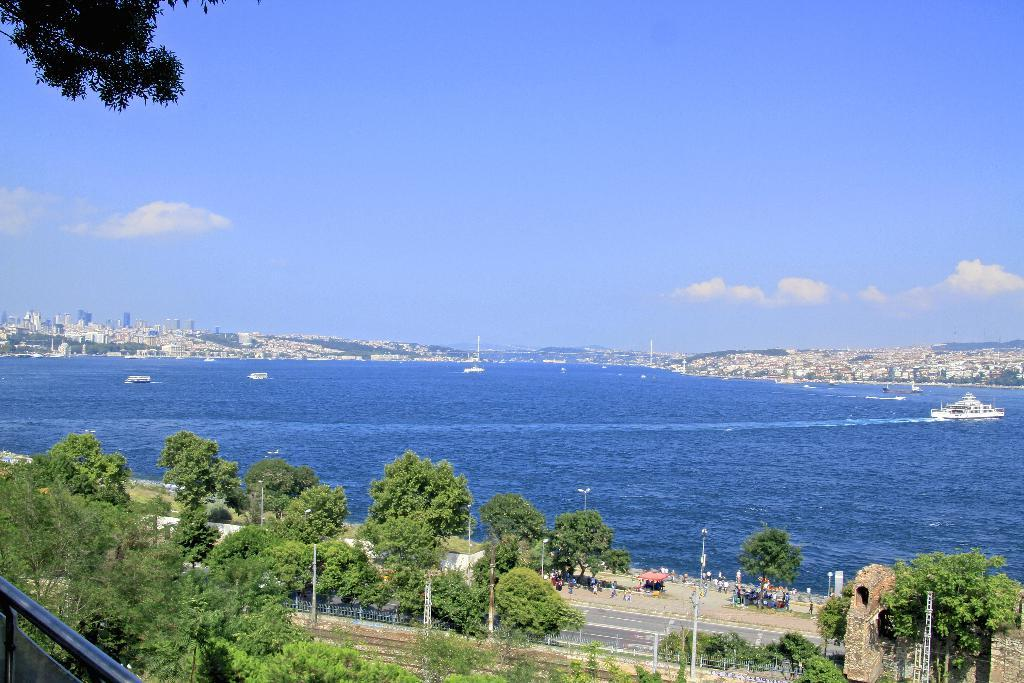What type of environment is shown in the image? The image is an outdoor scene. What color is the river in the image? The river is depicted in blue color. What type of water is the river? The river is described as freshwater. What structures can be seen in the distance? There are buildings visible in the distance. What is floating on the river? A boat is floating on the river. What type of vegetation is visible in the distance? There are trees visible in the distance. What else is present in the scene besides the river and the boat? A road is present in the scene. What type of bubble is floating near the dad in the image? There is no bubble or dad present in the image. What scientific experiment is being conducted in the image? There is no scientific experiment depicted in the image. 